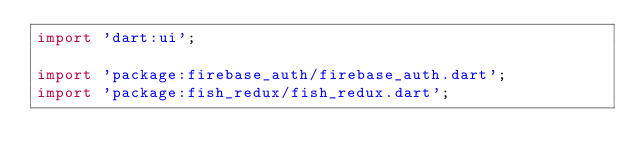Convert code to text. <code><loc_0><loc_0><loc_500><loc_500><_Dart_>import 'dart:ui';

import 'package:firebase_auth/firebase_auth.dart';
import 'package:fish_redux/fish_redux.dart';</code> 